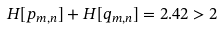<formula> <loc_0><loc_0><loc_500><loc_500>H [ p _ { m , n } ] + H [ q _ { m , n } ] = 2 . 4 2 > 2</formula> 